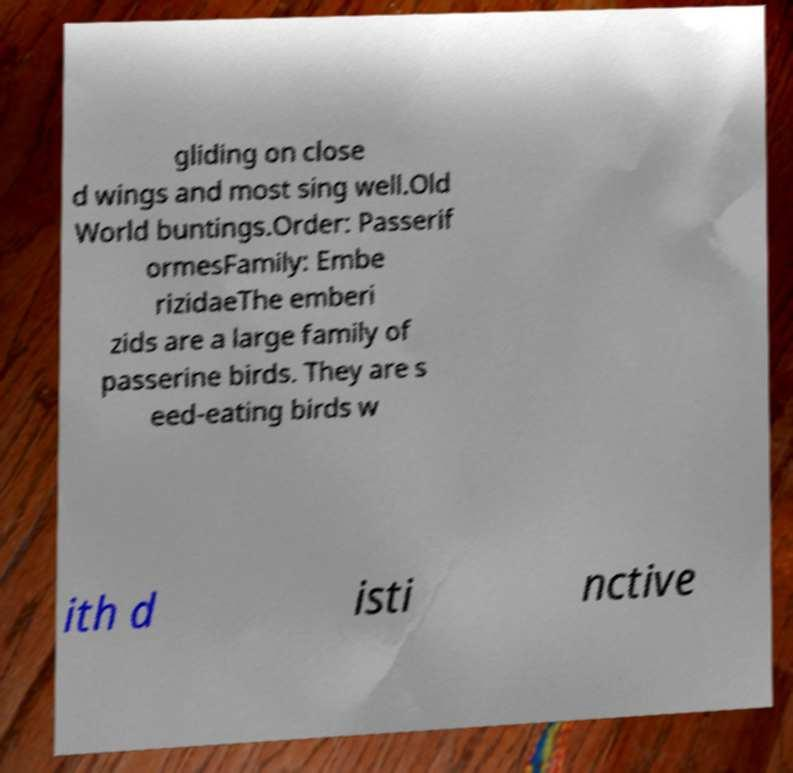For documentation purposes, I need the text within this image transcribed. Could you provide that? gliding on close d wings and most sing well.Old World buntings.Order: Passerif ormesFamily: Embe rizidaeThe emberi zids are a large family of passerine birds. They are s eed-eating birds w ith d isti nctive 